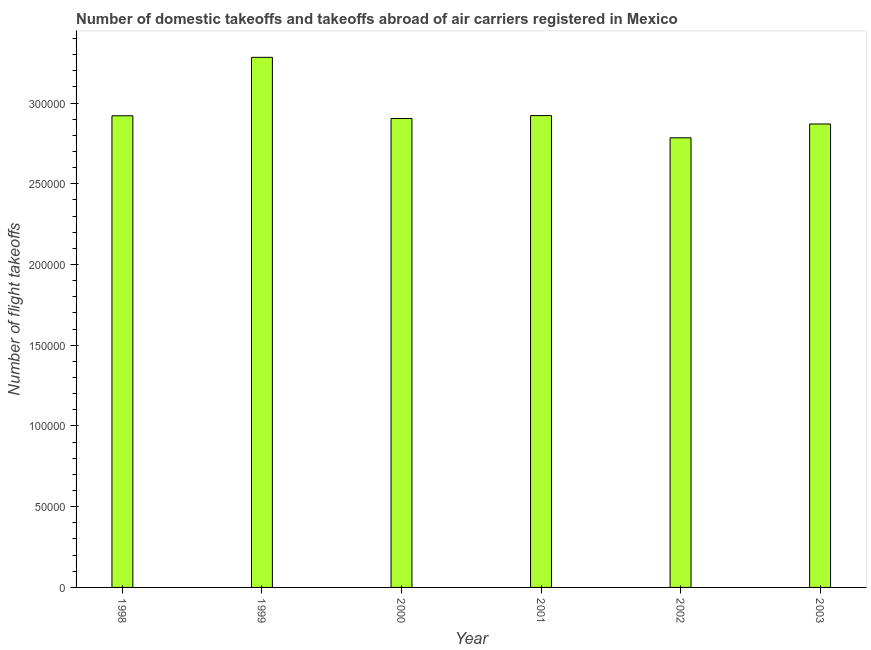Does the graph contain any zero values?
Ensure brevity in your answer.  No. What is the title of the graph?
Provide a short and direct response. Number of domestic takeoffs and takeoffs abroad of air carriers registered in Mexico. What is the label or title of the X-axis?
Give a very brief answer. Year. What is the label or title of the Y-axis?
Offer a terse response. Number of flight takeoffs. What is the number of flight takeoffs in 2002?
Offer a very short reply. 2.78e+05. Across all years, what is the maximum number of flight takeoffs?
Your answer should be compact. 3.28e+05. Across all years, what is the minimum number of flight takeoffs?
Provide a short and direct response. 2.78e+05. What is the sum of the number of flight takeoffs?
Offer a terse response. 1.77e+06. What is the difference between the number of flight takeoffs in 1998 and 2001?
Your answer should be very brief. -108. What is the average number of flight takeoffs per year?
Keep it short and to the point. 2.95e+05. What is the median number of flight takeoffs?
Provide a short and direct response. 2.91e+05. In how many years, is the number of flight takeoffs greater than 90000 ?
Provide a short and direct response. 6. Do a majority of the years between 2002 and 2000 (inclusive) have number of flight takeoffs greater than 120000 ?
Provide a succinct answer. Yes. What is the ratio of the number of flight takeoffs in 1999 to that in 2002?
Make the answer very short. 1.18. Is the number of flight takeoffs in 1998 less than that in 2000?
Make the answer very short. No. What is the difference between the highest and the second highest number of flight takeoffs?
Give a very brief answer. 3.61e+04. Is the sum of the number of flight takeoffs in 1999 and 2000 greater than the maximum number of flight takeoffs across all years?
Ensure brevity in your answer.  Yes. What is the difference between the highest and the lowest number of flight takeoffs?
Your answer should be compact. 4.98e+04. Are all the bars in the graph horizontal?
Provide a short and direct response. No. How many years are there in the graph?
Give a very brief answer. 6. Are the values on the major ticks of Y-axis written in scientific E-notation?
Your answer should be compact. No. What is the Number of flight takeoffs of 1998?
Provide a short and direct response. 2.92e+05. What is the Number of flight takeoffs of 1999?
Make the answer very short. 3.28e+05. What is the Number of flight takeoffs in 2000?
Keep it short and to the point. 2.90e+05. What is the Number of flight takeoffs in 2001?
Keep it short and to the point. 2.92e+05. What is the Number of flight takeoffs in 2002?
Ensure brevity in your answer.  2.78e+05. What is the Number of flight takeoffs of 2003?
Provide a succinct answer. 2.87e+05. What is the difference between the Number of flight takeoffs in 1998 and 1999?
Provide a succinct answer. -3.62e+04. What is the difference between the Number of flight takeoffs in 1998 and 2000?
Make the answer very short. 1688. What is the difference between the Number of flight takeoffs in 1998 and 2001?
Keep it short and to the point. -108. What is the difference between the Number of flight takeoffs in 1998 and 2002?
Keep it short and to the point. 1.36e+04. What is the difference between the Number of flight takeoffs in 1998 and 2003?
Keep it short and to the point. 5083. What is the difference between the Number of flight takeoffs in 1999 and 2000?
Your response must be concise. 3.79e+04. What is the difference between the Number of flight takeoffs in 1999 and 2001?
Your answer should be very brief. 3.61e+04. What is the difference between the Number of flight takeoffs in 1999 and 2002?
Your response must be concise. 4.98e+04. What is the difference between the Number of flight takeoffs in 1999 and 2003?
Provide a succinct answer. 4.13e+04. What is the difference between the Number of flight takeoffs in 2000 and 2001?
Your answer should be very brief. -1796. What is the difference between the Number of flight takeoffs in 2000 and 2002?
Your answer should be very brief. 1.20e+04. What is the difference between the Number of flight takeoffs in 2000 and 2003?
Provide a short and direct response. 3395. What is the difference between the Number of flight takeoffs in 2001 and 2002?
Make the answer very short. 1.38e+04. What is the difference between the Number of flight takeoffs in 2001 and 2003?
Offer a terse response. 5191. What is the difference between the Number of flight takeoffs in 2002 and 2003?
Ensure brevity in your answer.  -8561. What is the ratio of the Number of flight takeoffs in 1998 to that in 1999?
Your response must be concise. 0.89. What is the ratio of the Number of flight takeoffs in 1998 to that in 2000?
Your answer should be compact. 1.01. What is the ratio of the Number of flight takeoffs in 1998 to that in 2002?
Give a very brief answer. 1.05. What is the ratio of the Number of flight takeoffs in 1999 to that in 2000?
Your answer should be very brief. 1.13. What is the ratio of the Number of flight takeoffs in 1999 to that in 2001?
Your response must be concise. 1.12. What is the ratio of the Number of flight takeoffs in 1999 to that in 2002?
Offer a terse response. 1.18. What is the ratio of the Number of flight takeoffs in 1999 to that in 2003?
Provide a succinct answer. 1.14. What is the ratio of the Number of flight takeoffs in 2000 to that in 2001?
Your response must be concise. 0.99. What is the ratio of the Number of flight takeoffs in 2000 to that in 2002?
Provide a succinct answer. 1.04. What is the ratio of the Number of flight takeoffs in 2001 to that in 2002?
Offer a terse response. 1.05. What is the ratio of the Number of flight takeoffs in 2001 to that in 2003?
Provide a succinct answer. 1.02. What is the ratio of the Number of flight takeoffs in 2002 to that in 2003?
Your response must be concise. 0.97. 